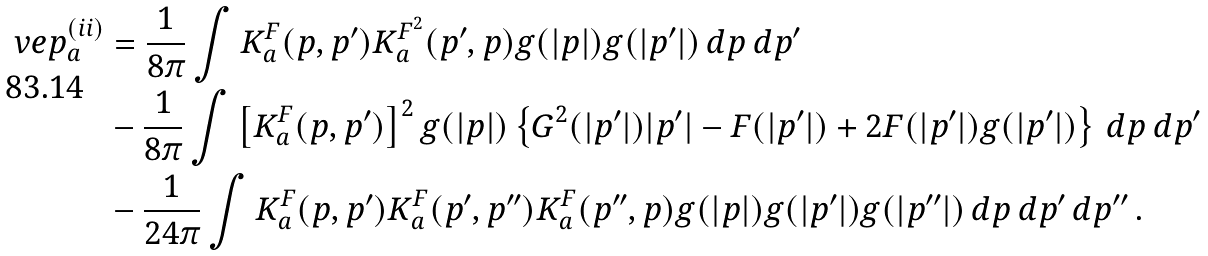<formula> <loc_0><loc_0><loc_500><loc_500>\ v e p _ { a } ^ { ( i i ) } & = \frac { 1 } { 8 \pi } \int K ^ { F } _ { a } ( p , p ^ { \prime } ) K ^ { F ^ { 2 } } _ { a } ( p ^ { \prime } , p ) g ( | p | ) g ( | p ^ { \prime } | ) \, d p \, d p ^ { \prime } \\ & - \frac { 1 } { 8 \pi } \int \left [ K ^ { F } _ { a } ( p , p ^ { \prime } ) \right ] ^ { 2 } g ( | p | ) \left \{ G ^ { 2 } ( | p ^ { \prime } | ) | p ^ { \prime } | - F ( | p ^ { \prime } | ) + 2 F ( | p ^ { \prime } | ) g ( | p ^ { \prime } | ) \right \} \, d p \, d p ^ { \prime } \\ & - \frac { 1 } { 2 4 \pi } \int K ^ { F } _ { a } ( p , p ^ { \prime } ) K ^ { F } _ { a } ( p ^ { \prime } , p ^ { \prime \prime } ) K ^ { F } _ { a } ( p ^ { \prime \prime } , p ) g ( | p | ) g ( | p ^ { \prime } | ) g ( | p ^ { \prime \prime } | ) \, d p \, d p ^ { \prime } \, d p ^ { \prime \prime } \, .</formula> 